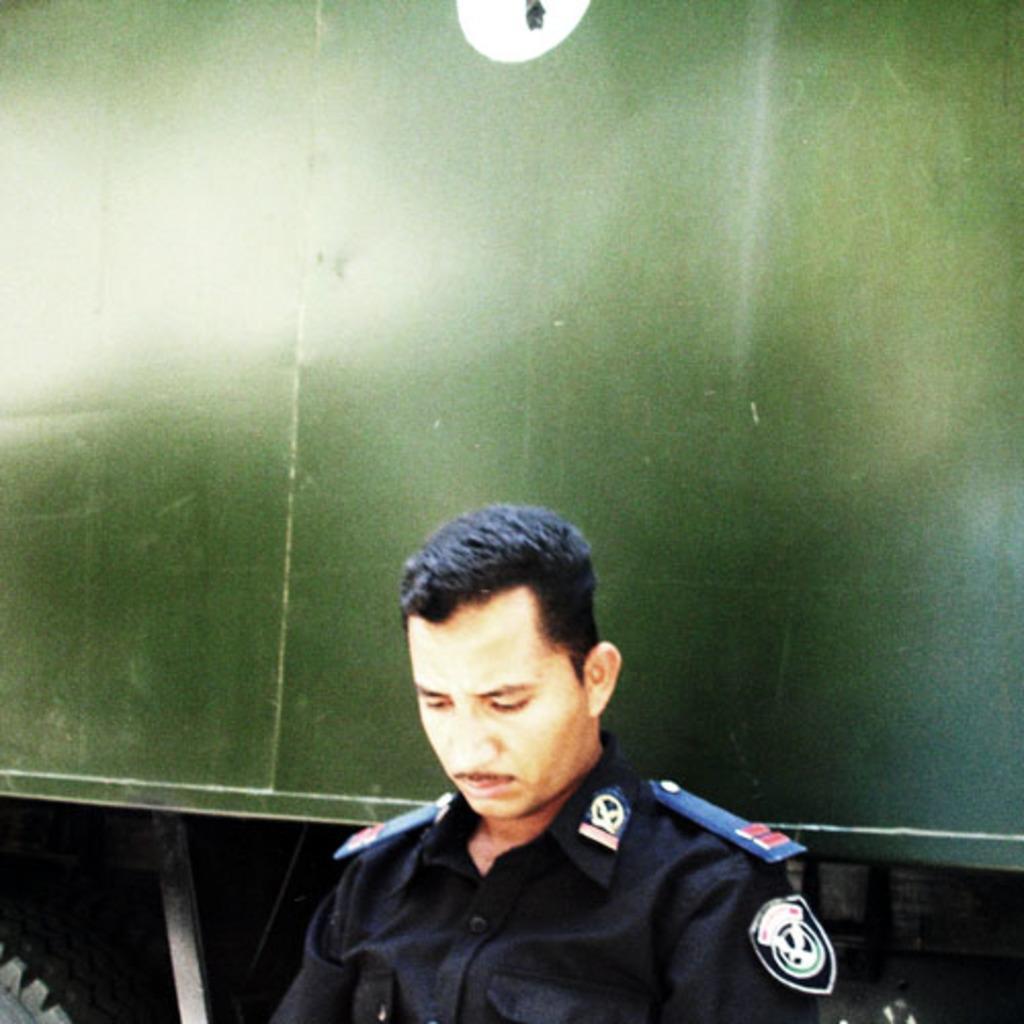Can you describe this image briefly? In this image we can see a man and a motor vehicle in the background. 